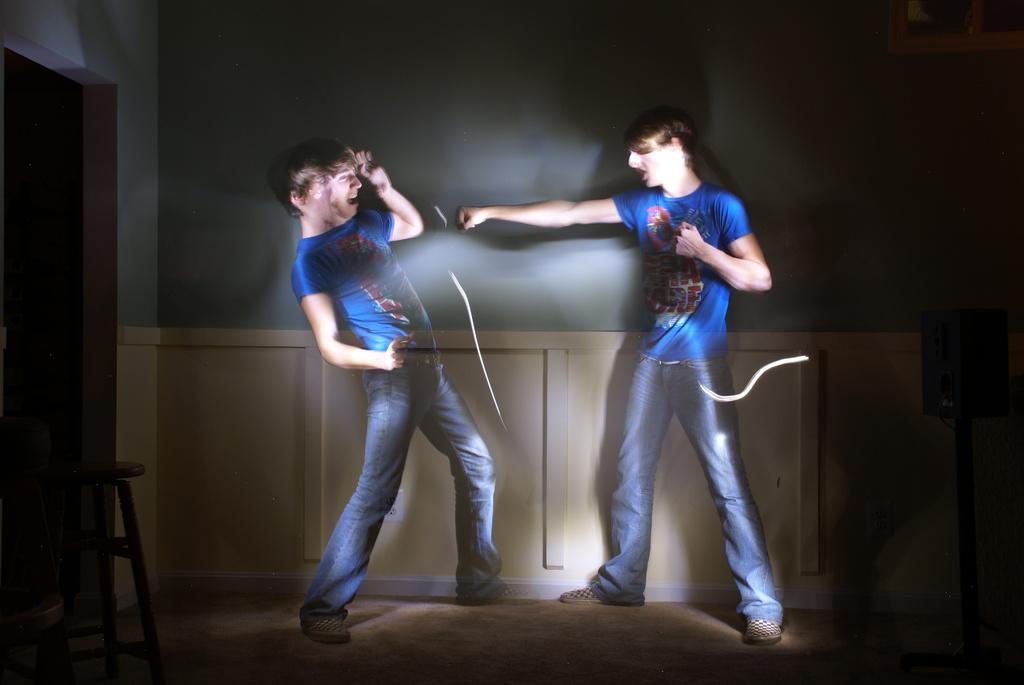How many people are present in the image? There are two people standing in the image. What is located on the left side of the people? There is a stool on the left side of the people. What can be seen behind the people? There is a wall behind the people. What type of cannon is being fired by the people in the image? There is no cannon present in the image; it only features two people standing near a stool and a wall. What color is the skin of the people in the image? The provided facts do not mention the color of the people's skin, so it cannot be determined from the image. 